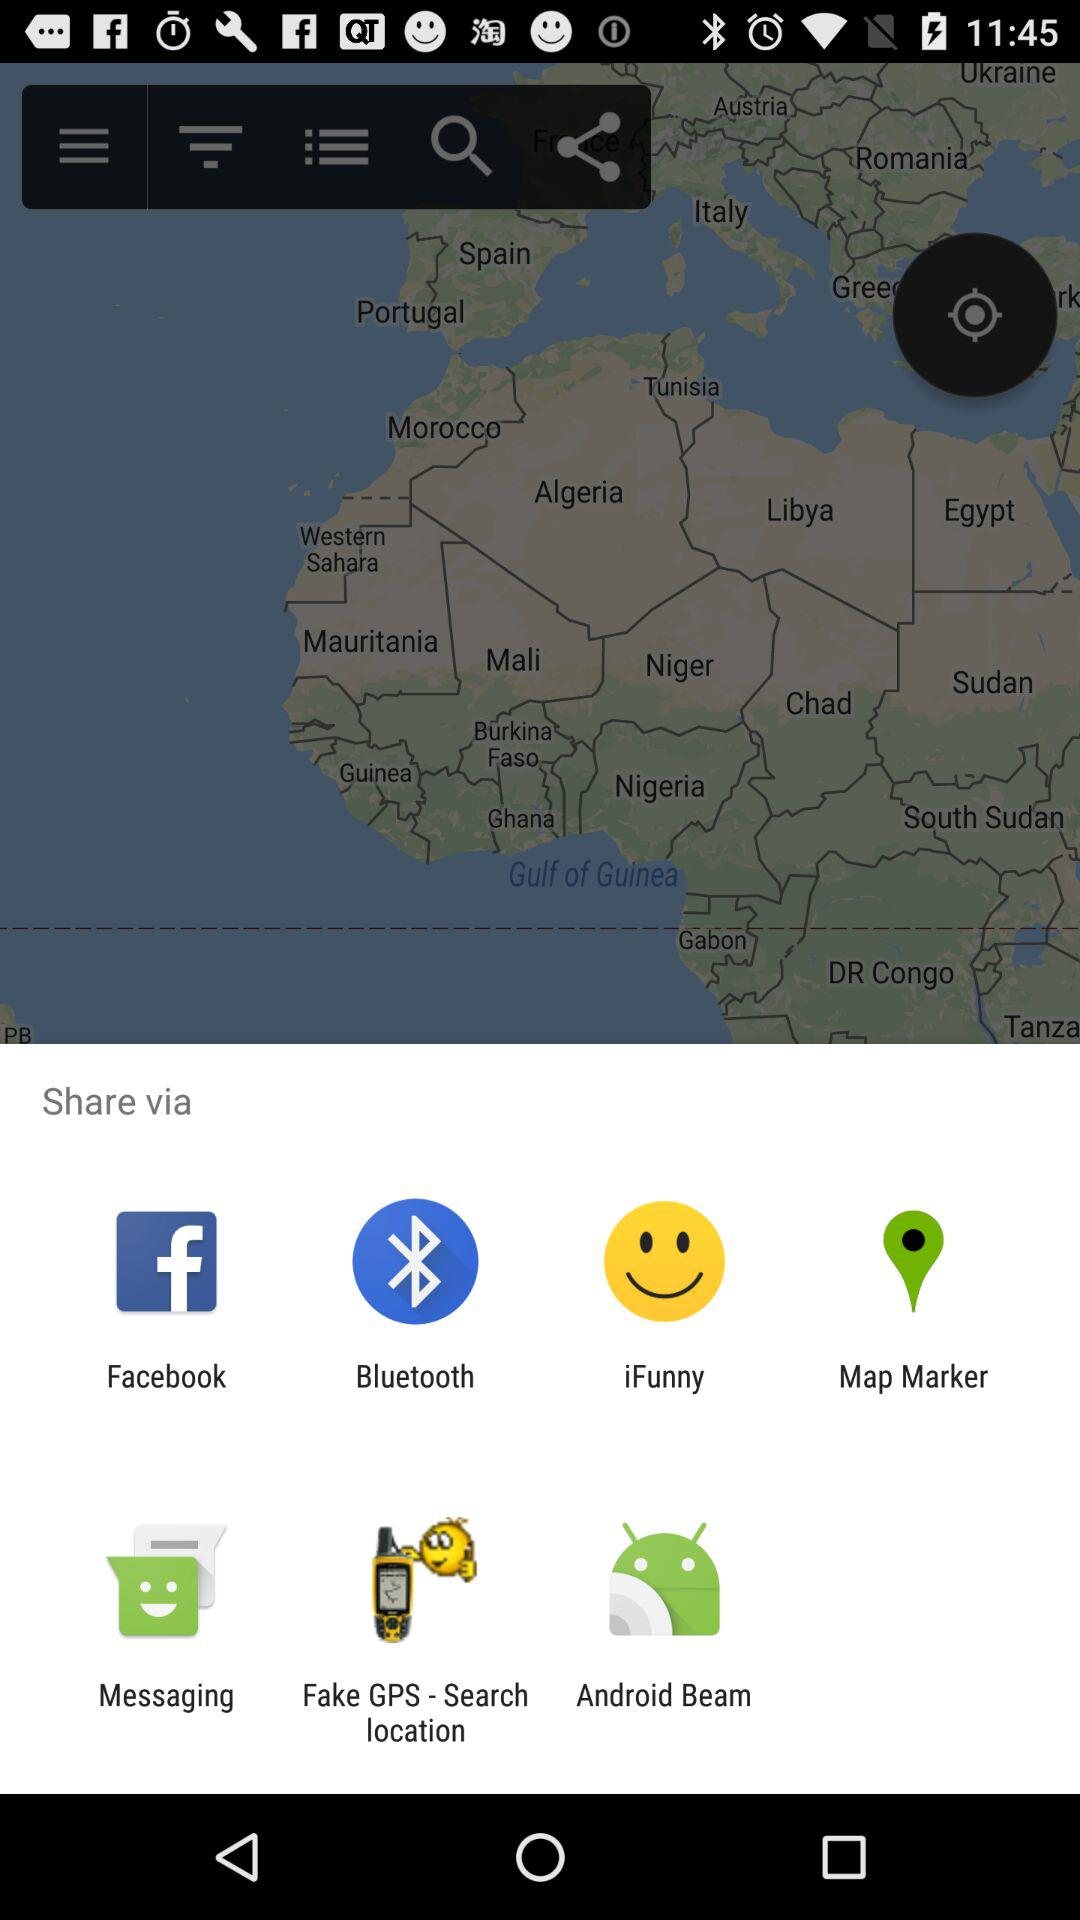What are the sharing options? The sharing options are "Facebook", "Bluetooth", "iFunny", "Map Marker", "Messaging", "Fake GPS - Search location" and "Android Beam". 